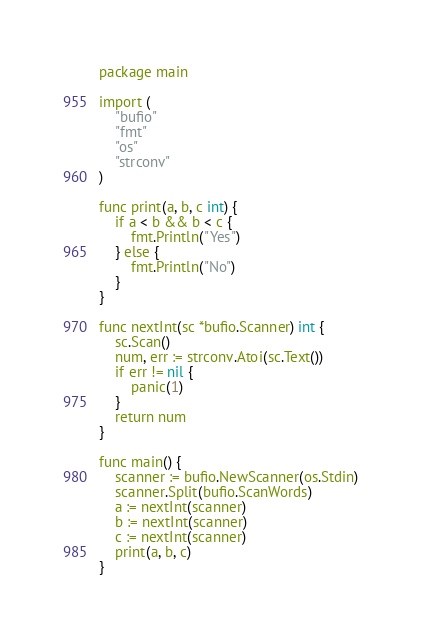Convert code to text. <code><loc_0><loc_0><loc_500><loc_500><_Go_>package main

import (
	"bufio"
	"fmt"
	"os"
	"strconv"
)

func print(a, b, c int) {
	if a < b && b < c {
		fmt.Println("Yes")
	} else {
		fmt.Println("No")
	}
}

func nextInt(sc *bufio.Scanner) int {
	sc.Scan()
	num, err := strconv.Atoi(sc.Text())
	if err != nil {
		panic(1)
	}
	return num
}

func main() {
	scanner := bufio.NewScanner(os.Stdin)
	scanner.Split(bufio.ScanWords)
	a := nextInt(scanner)
	b := nextInt(scanner)
	c := nextInt(scanner)
	print(a, b, c)
}

</code> 